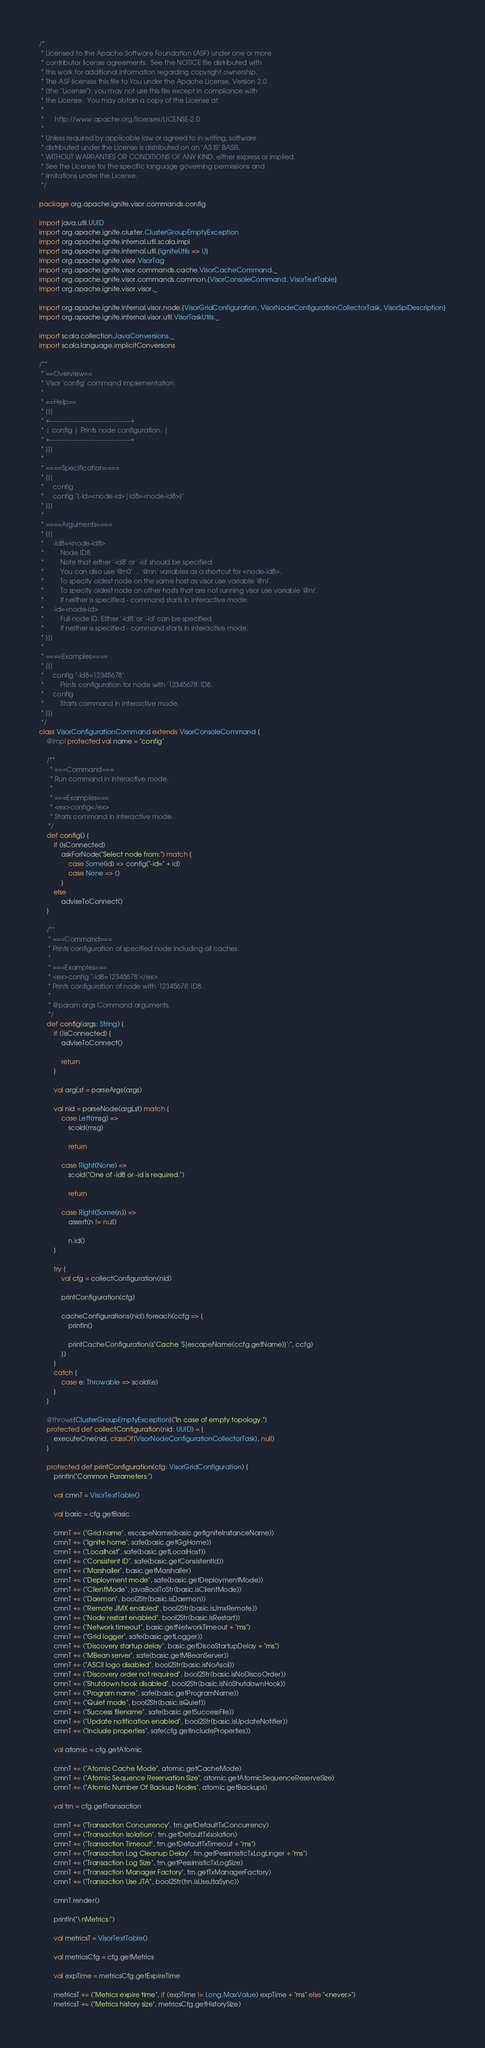Convert code to text. <code><loc_0><loc_0><loc_500><loc_500><_Scala_>/*
 * Licensed to the Apache Software Foundation (ASF) under one or more
 * contributor license agreements.  See the NOTICE file distributed with
 * this work for additional information regarding copyright ownership.
 * The ASF licenses this file to You under the Apache License, Version 2.0
 * (the "License"); you may not use this file except in compliance with
 * the License.  You may obtain a copy of the License at
 *
 *      http://www.apache.org/licenses/LICENSE-2.0
 *
 * Unless required by applicable law or agreed to in writing, software
 * distributed under the License is distributed on an "AS IS" BASIS,
 * WITHOUT WARRANTIES OR CONDITIONS OF ANY KIND, either express or implied.
 * See the License for the specific language governing permissions and
 * limitations under the License.
 */

package org.apache.ignite.visor.commands.config

import java.util.UUID
import org.apache.ignite.cluster.ClusterGroupEmptyException
import org.apache.ignite.internal.util.scala.impl
import org.apache.ignite.internal.util.{IgniteUtils => U}
import org.apache.ignite.visor.VisorTag
import org.apache.ignite.visor.commands.cache.VisorCacheCommand._
import org.apache.ignite.visor.commands.common.{VisorConsoleCommand, VisorTextTable}
import org.apache.ignite.visor.visor._

import org.apache.ignite.internal.visor.node.{VisorGridConfiguration, VisorNodeConfigurationCollectorTask, VisorSpiDescription}
import org.apache.ignite.internal.visor.util.VisorTaskUtils._

import scala.collection.JavaConversions._
import scala.language.implicitConversions

/**
 * ==Overview==
 * Visor 'config' command implementation.
 *
 * ==Help==
 * {{{
 * +-------------------------------------+
 * | config | Prints node configuration. |
 * +-------------------------------------+
 * }}}
 *
 * ====Specification====
 * {{{
 *     config
 *     config "{-id=<node-id>|id8=<node-id8>}"
 * }}}
 *
 * ====Arguments====
 * {{{
 *     -id8=<node-id8>
 *         Node ID8.
 *         Note that either '-id8' or '-id' should be specified.
 *         You can also use '@n0' ... '@nn' variables as a shortcut for <node-id8>.
 *         To specify oldest node on the same host as visor use variable '@nl'.
 *         To specify oldest node on other hosts that are not running visor use variable '@nr'.
 *         If neither is specified - command starts in interactive mode.
 *     -id=<node-id>
 *         Full node ID. Either '-id8' or '-id' can be specified.
 *         If neither is specified - command starts in interactive mode.
 * }}}
 *
 * ====Examples====
 * {{{
 *     config "-id8=12345678"
 *         Prints configuration for node with '12345678' ID8.
 *     config
 *         Starts command in interactive mode.
 * }}}
 */
class VisorConfigurationCommand extends VisorConsoleCommand {
    @impl protected val name = "config"

    /**
      * ===Command===
      * Run command in interactive mode.
      *
      * ===Examples===
      * <ex>config</ex>
      * Starts command in interactive mode.
     */
    def config() {
        if (isConnected)
            askForNode("Select node from:") match {
                case Some(id) => config("-id=" + id)
                case None => ()
            }
        else
            adviseToConnect()
    }

    /**
     * ===Command===
     * Prints configuration of specified node including all caches.
     *
     * ===Examples===
     * <ex>config "-id8=12345678"</ex>
     * Prints configuration of node with '12345678' ID8.
     *
     * @param args Command arguments.
     */
    def config(args: String) {
        if (!isConnected) {
            adviseToConnect()

            return
        }

        val argLst = parseArgs(args)

        val nid = parseNode(argLst) match {
            case Left(msg) =>
                scold(msg)

                return

            case Right(None) =>
                scold("One of -id8 or -id is required.")

                return

            case Right(Some(n)) =>
                assert(n != null)

                n.id()
        }

        try {
            val cfg = collectConfiguration(nid)

            printConfiguration(cfg)

            cacheConfigurations(nid).foreach(ccfg => {
                println()

                printCacheConfiguration(s"Cache '${escapeName(ccfg.getName)}':", ccfg)
            })
        }
        catch {
            case e: Throwable => scold(e)
        }
    }

    @throws[ClusterGroupEmptyException]("In case of empty topology.")
    protected def collectConfiguration(nid: UUID) = {
        executeOne(nid, classOf[VisorNodeConfigurationCollectorTask], null)
    }

    protected def printConfiguration(cfg: VisorGridConfiguration) {
        println("Common Parameters:")

        val cmnT = VisorTextTable()

        val basic = cfg.getBasic

        cmnT += ("Grid name", escapeName(basic.getIgniteInstanceName))
        cmnT += ("Ignite home", safe(basic.getGgHome))
        cmnT += ("Localhost", safe(basic.getLocalHost))
        cmnT += ("Consistent ID", safe(basic.getConsistentId))
        cmnT += ("Marshaller", basic.getMarshaller)
        cmnT += ("Deployment mode", safe(basic.getDeploymentMode))
        cmnT += ("ClientMode", javaBoolToStr(basic.isClientMode))
        cmnT += ("Daemon", bool2Str(basic.isDaemon))
        cmnT += ("Remote JMX enabled", bool2Str(basic.isJmxRemote))
        cmnT += ("Node restart enabled", bool2Str(basic.isRestart))
        cmnT += ("Network timeout", basic.getNetworkTimeout + "ms")
        cmnT += ("Grid logger", safe(basic.getLogger))
        cmnT += ("Discovery startup delay", basic.getDiscoStartupDelay + "ms")
        cmnT += ("MBean server", safe(basic.getMBeanServer))
        cmnT += ("ASCII logo disabled", bool2Str(basic.isNoAscii))
        cmnT += ("Discovery order not required", bool2Str(basic.isNoDiscoOrder))
        cmnT += ("Shutdown hook disabled", bool2Str(basic.isNoShutdownHook))
        cmnT += ("Program name", safe(basic.getProgramName))
        cmnT += ("Quiet mode", bool2Str(basic.isQuiet))
        cmnT += ("Success filename", safe(basic.getSuccessFile))
        cmnT += ("Update notification enabled", bool2Str(basic.isUpdateNotifier))
        cmnT += ("Include properties", safe(cfg.getIncludeProperties))

        val atomic = cfg.getAtomic

        cmnT += ("Atomic Cache Mode", atomic.getCacheMode)
        cmnT += ("Atomic Sequence Reservation Size", atomic.getAtomicSequenceReserveSize)
        cmnT += ("Atomic Number Of Backup Nodes", atomic.getBackups)

        val trn = cfg.getTransaction

        cmnT += ("Transaction Concurrency", trn.getDefaultTxConcurrency)
        cmnT += ("Transaction Isolation", trn.getDefaultTxIsolation)
        cmnT += ("Transaction Timeout", trn.getDefaultTxTimeout + "ms")
        cmnT += ("Transaction Log Cleanup Delay", trn.getPessimisticTxLogLinger + "ms")
        cmnT += ("Transaction Log Size", trn.getPessimisticTxLogSize)
        cmnT += ("Transaction Manager Factory", trn.getTxManagerFactory)
        cmnT += ("Transaction Use JTA", bool2Str(trn.isUseJtaSync))

        cmnT.render()

        println("\nMetrics:")

        val metricsT = VisorTextTable()

        val metricsCfg = cfg.getMetrics

        val expTime = metricsCfg.getExpireTime

        metricsT += ("Metrics expire time", if (expTime != Long.MaxValue) expTime + "ms" else "<never>")
        metricsT += ("Metrics history size", metricsCfg.getHistorySize)</code> 